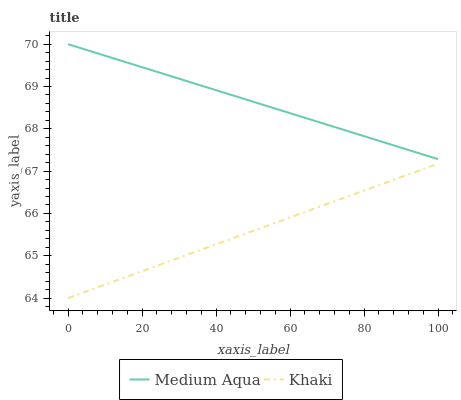Does Khaki have the minimum area under the curve?
Answer yes or no. Yes. Does Medium Aqua have the maximum area under the curve?
Answer yes or no. Yes. Does Medium Aqua have the minimum area under the curve?
Answer yes or no. No. Is Medium Aqua the smoothest?
Answer yes or no. Yes. Is Khaki the roughest?
Answer yes or no. Yes. Is Medium Aqua the roughest?
Answer yes or no. No. Does Khaki have the lowest value?
Answer yes or no. Yes. Does Medium Aqua have the lowest value?
Answer yes or no. No. Does Medium Aqua have the highest value?
Answer yes or no. Yes. Is Khaki less than Medium Aqua?
Answer yes or no. Yes. Is Medium Aqua greater than Khaki?
Answer yes or no. Yes. Does Khaki intersect Medium Aqua?
Answer yes or no. No. 